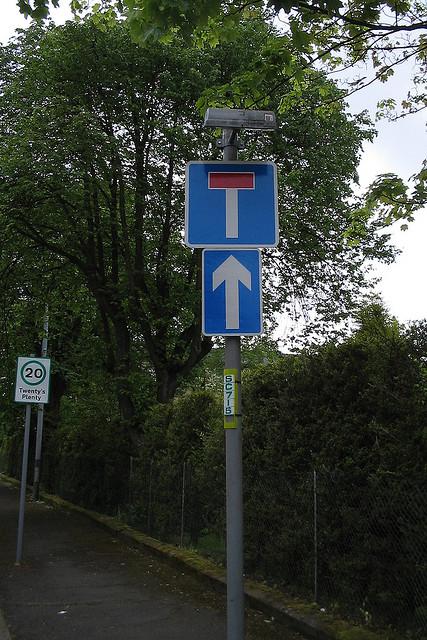What do you do at this kind of sign?
Answer briefly. Go straight. What season is most likely featured here?
Quick response, please. Spring. What color are the trees?
Be succinct. Green. What number is on the sign?
Short answer required. 20. Which way is the arrow pointing?
Give a very brief answer. Up. What color are the signs?
Write a very short answer. Blue. What Letters are on the sign?
Short answer required. T. What does the sign say?
Give a very brief answer. Up. Is the sign illuminated at night?
Answer briefly. Yes. 